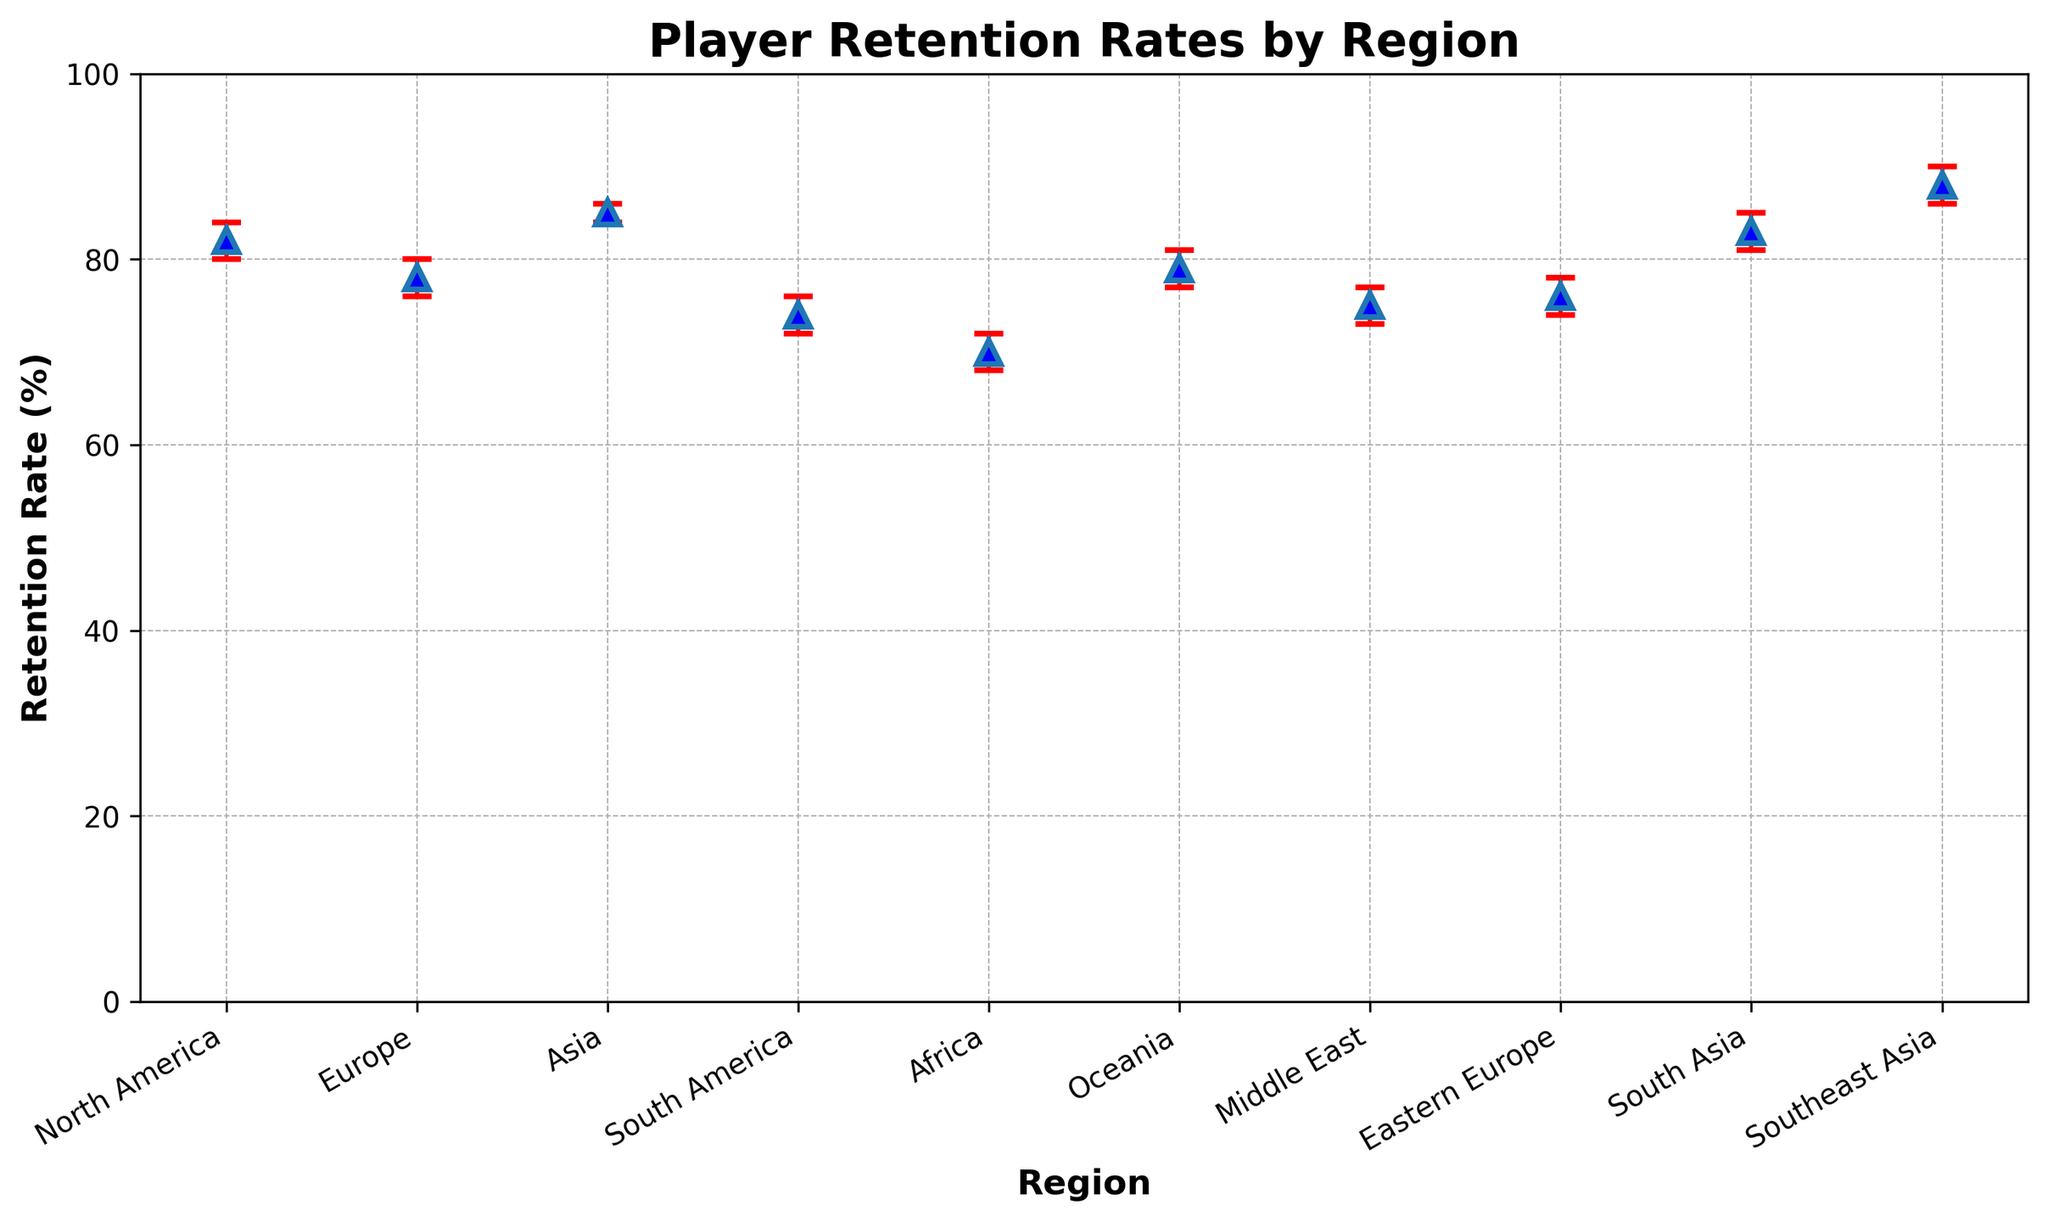Which region has the highest player retention rate? The Southeast Asia region has the highest retention rate at 88%. This is directly observable on the chart as the tallest point.
Answer: Southeast Asia Which region has the lowest player retention rate? The Africa region has the lowest retention rate at 70%. This is directly observable on the chart as the shortest point.
Answer: Africa What are the confidence intervals for Europe? The confidence intervals for Europe are represented by the error bars around the point for Europe. The lower bound is 76%, and the upper bound is 80%.
Answer: 76% to 80% Which region has a retention rate just below 80%? Europe has a retention rate just below 80% at 78%. This can be seen by locating the point for Europe on the chart.
Answer: Europe Is the retention rate for Asia higher than for South America? Yes, the retention rate for Asia (85%) is higher than for South America (74%). This can be determined by comparing the heights of the points for these regions on the chart.
Answer: Yes Which region has a similar retention rate to North America? South Asia has a similar retention rate to North America. North America's retention rate is 82%, and South Asia's retention rate is 83%, both are visually very close on the chart.
Answer: South Asia What is the difference in retention rates between Southeast Asia and Africa? The retention rate for Southeast Asia is 88%, and for Africa, it is 70%. The difference is 88% - 70% = 18%.
Answer: 18% Among Oceania, North America, and Europe, which region has the highest retention rate? Among these three regions, North America has the highest retention rate at 82%. This can be determined by comparing the points for these regions.
Answer: North America Which regions have retention rates with confidence intervals that overlap? The confidence intervals for Europe (76% to 80%) and Eastern Europe (74% to 78%) overlap between 76% and 78%. This is seen by examining the ranges of the error bars.
Answer: Europe and Eastern Europe What are the average retention rates for North America, Europe, and Asia? The retention rates for these regions are North America (82%), Europe (78%), and Asia (85%). The average is calculated as (82 + 78 + 85) / 3 = 245 / 3 ≈ 81.67%.
Answer: 81.67% 